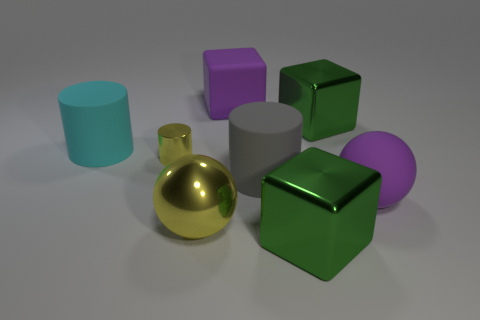Are there any other things that have the same size as the yellow shiny cylinder?
Make the answer very short. No. There is a sphere that is the same material as the gray cylinder; what color is it?
Your response must be concise. Purple. The large thing that is the same color as the tiny cylinder is what shape?
Keep it short and to the point. Sphere. Does the metal cube that is in front of the big yellow metallic thing have the same size as the yellow metallic object behind the large matte sphere?
Offer a very short reply. No. What number of cubes are blue matte objects or cyan objects?
Your response must be concise. 0. Are the green object that is behind the cyan object and the cyan thing made of the same material?
Your answer should be very brief. No. What number of other things are there of the same size as the purple rubber ball?
Provide a succinct answer. 6. What number of small things are either brown rubber cylinders or yellow shiny things?
Provide a succinct answer. 1. Does the big matte block have the same color as the large rubber sphere?
Make the answer very short. Yes. Are there more green metallic cubes that are behind the gray thing than large metallic cubes to the left of the big cyan rubber cylinder?
Make the answer very short. Yes. 